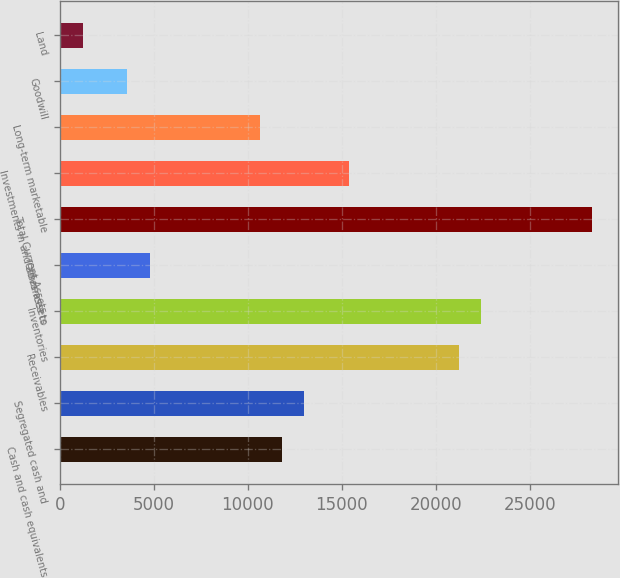Convert chart to OTSL. <chart><loc_0><loc_0><loc_500><loc_500><bar_chart><fcel>Cash and cash equivalents<fcel>Segregated cash and<fcel>Receivables<fcel>Inventories<fcel>Other assets<fcel>Total Current Assets<fcel>Investments in and advances to<fcel>Long-term marketable<fcel>Goodwill<fcel>Land<nl><fcel>11826<fcel>13000.6<fcel>21222.8<fcel>22397.4<fcel>4778.4<fcel>28270.4<fcel>15349.8<fcel>10651.4<fcel>3603.8<fcel>1254.6<nl></chart> 